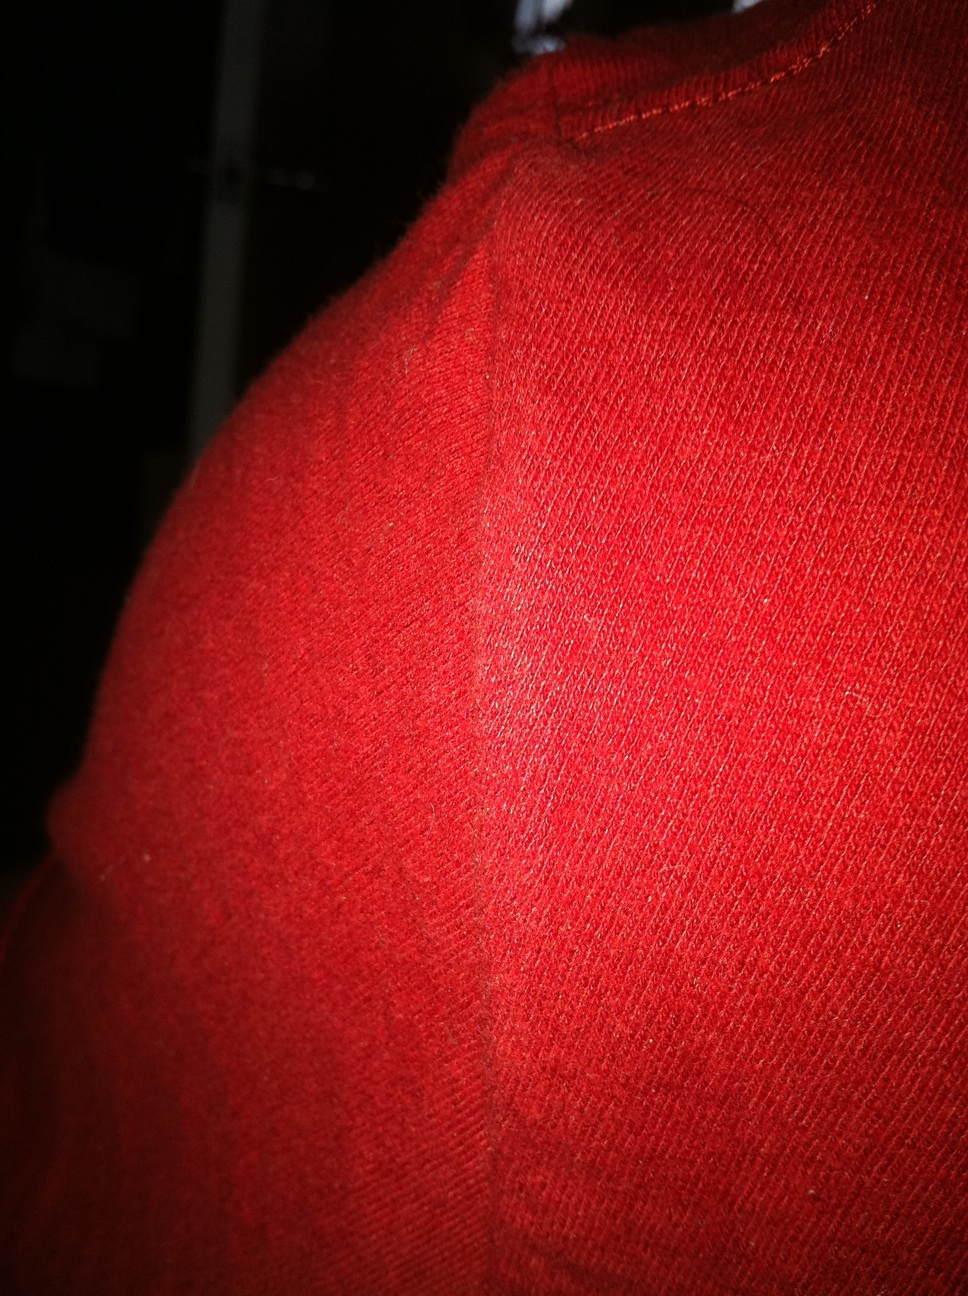What realistic scenarios could this fabric be a part of? (short response) This fabric could be used to create a beanie gifted as a heartfelt handmade present on Christmas morning, bringing a smile to a loved one's face. And how about a more detailed scenario? The fabric could be part of a memorable winter fair where vendors sell handcrafted red scarves and mittens, each crafted from this sharegpt4v/same cozy fabric. Families gather around bonfires, sipping on hot cocoa. Children, wrapped snugly in red beanies, play in the snow, creating lasting memories. The atmosphere is filled with laughter, the texture of the fabric now imbued with stories of joy and togetherness, capturing the essence of festive warmth that defines those chilly, yet heartwarming winter days. 